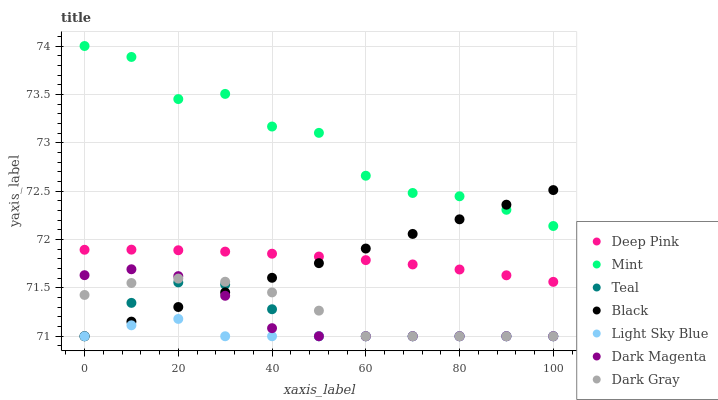Does Light Sky Blue have the minimum area under the curve?
Answer yes or no. Yes. Does Mint have the maximum area under the curve?
Answer yes or no. Yes. Does Dark Magenta have the minimum area under the curve?
Answer yes or no. No. Does Dark Magenta have the maximum area under the curve?
Answer yes or no. No. Is Black the smoothest?
Answer yes or no. Yes. Is Mint the roughest?
Answer yes or no. Yes. Is Dark Magenta the smoothest?
Answer yes or no. No. Is Dark Magenta the roughest?
Answer yes or no. No. Does Dark Magenta have the lowest value?
Answer yes or no. Yes. Does Mint have the lowest value?
Answer yes or no. No. Does Mint have the highest value?
Answer yes or no. Yes. Does Dark Magenta have the highest value?
Answer yes or no. No. Is Light Sky Blue less than Deep Pink?
Answer yes or no. Yes. Is Mint greater than Teal?
Answer yes or no. Yes. Does Light Sky Blue intersect Dark Gray?
Answer yes or no. Yes. Is Light Sky Blue less than Dark Gray?
Answer yes or no. No. Is Light Sky Blue greater than Dark Gray?
Answer yes or no. No. Does Light Sky Blue intersect Deep Pink?
Answer yes or no. No. 